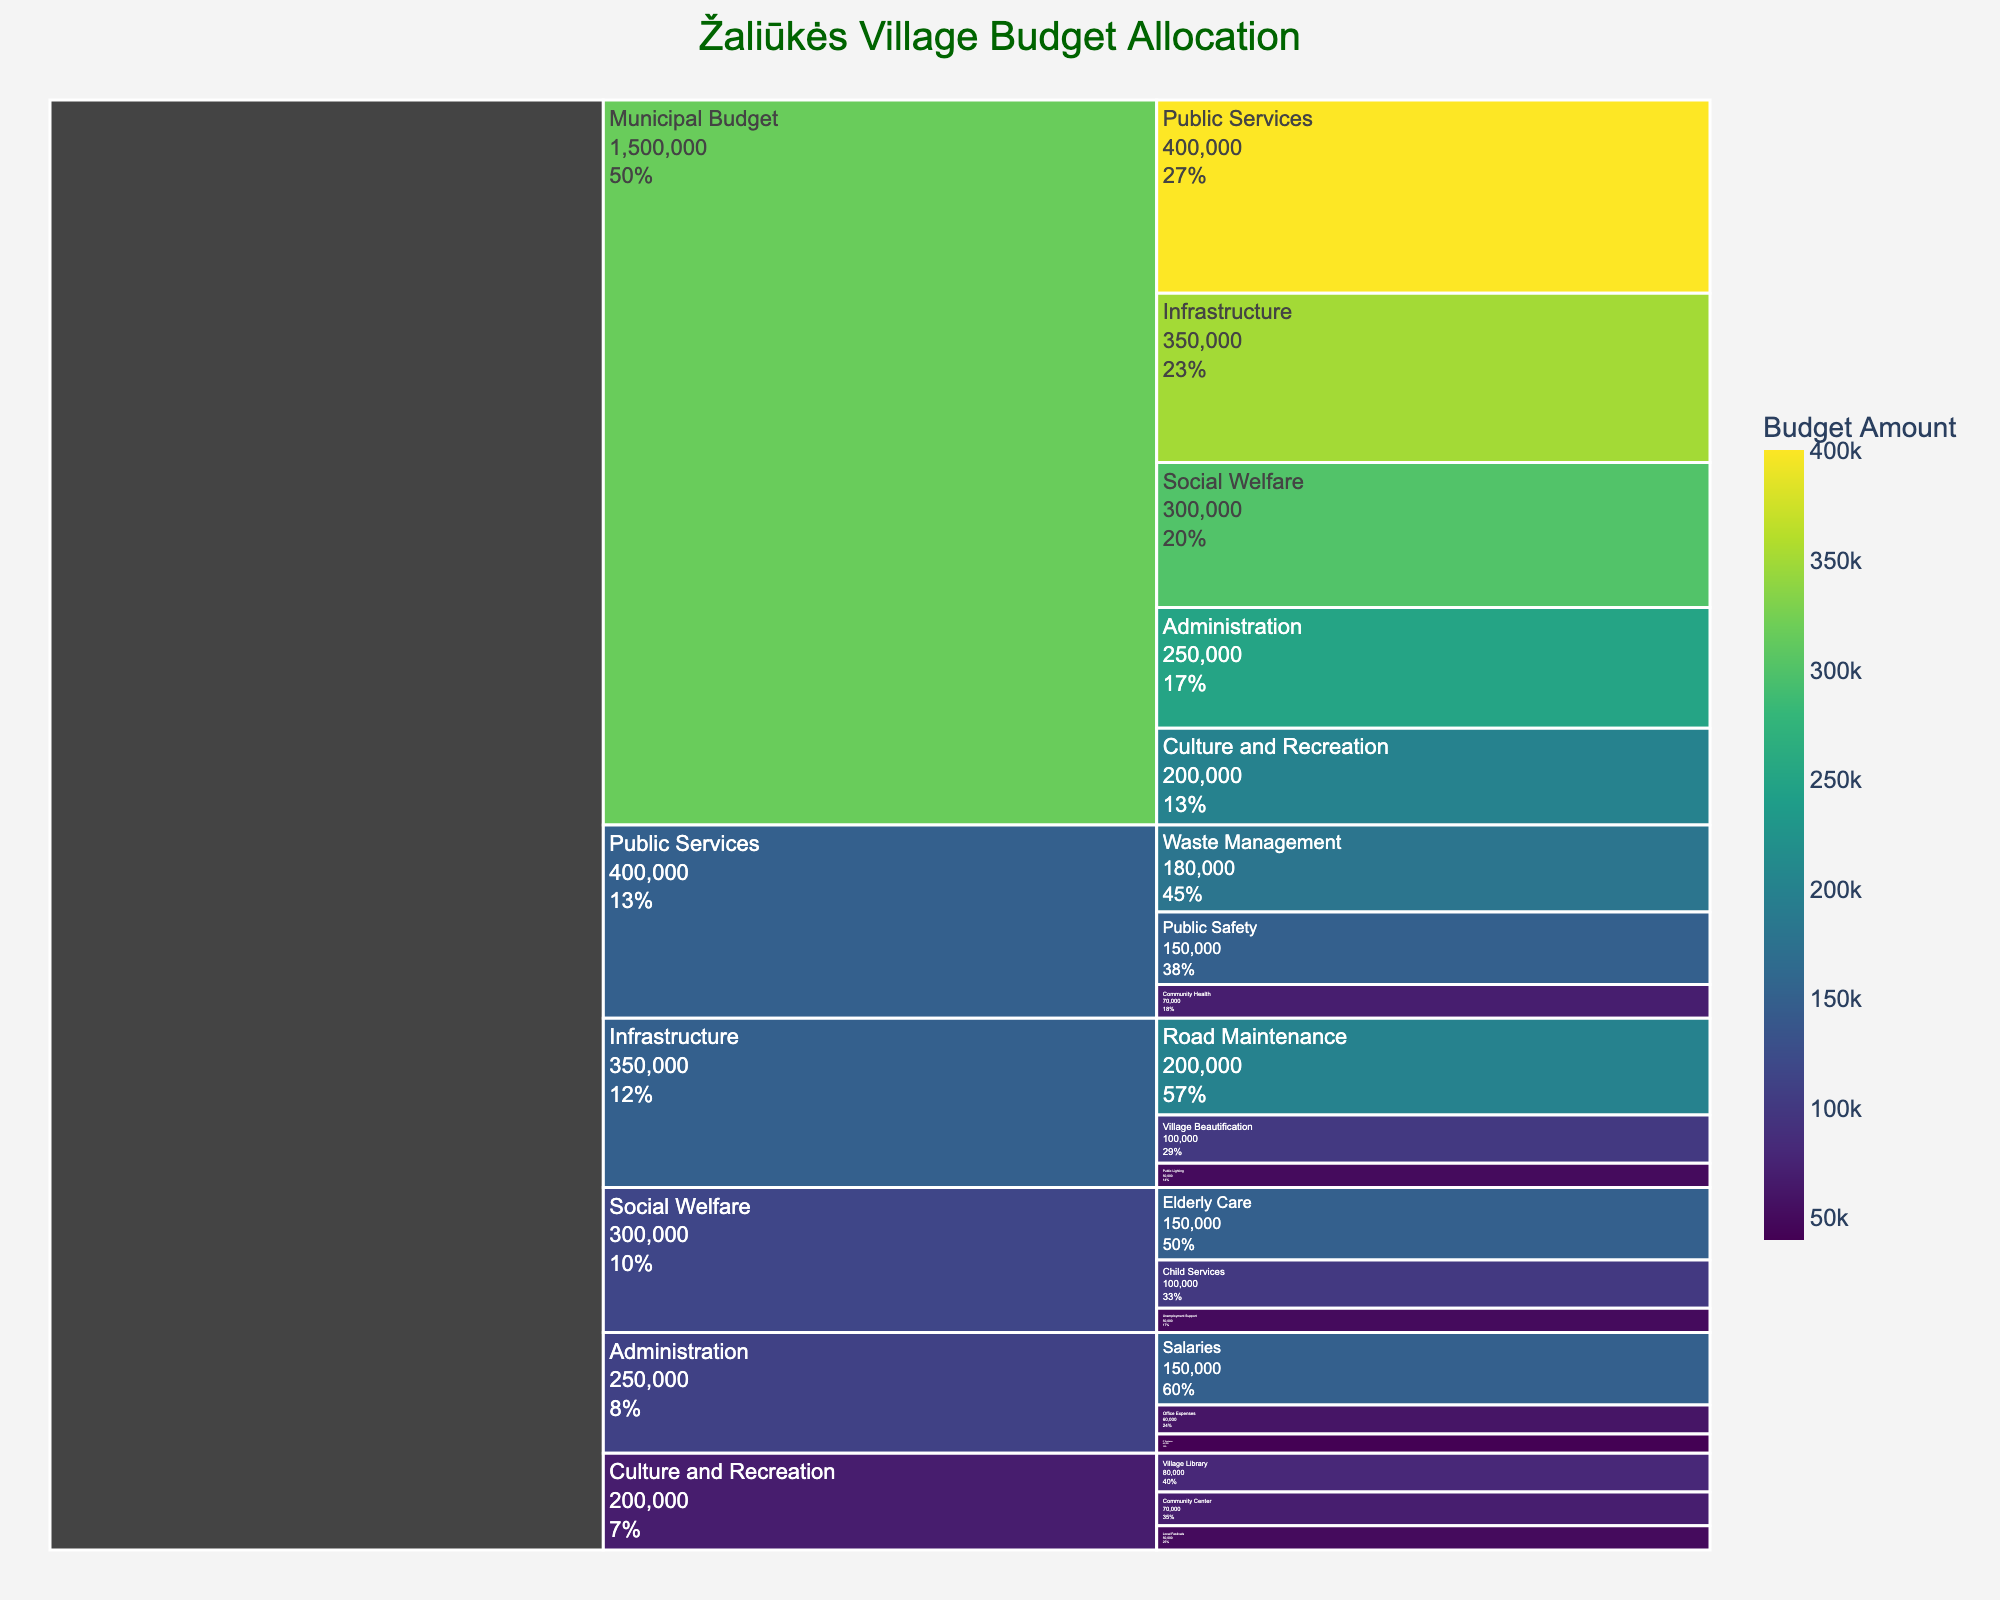What is the title of the icicle chart? The title is usually found at the top of the chart. In this case, it should clearly state the main subject being depicted, which is the budget allocation.
Answer: Žaliūkės Village Budget Allocation Which category has the highest budget allocation? To determine the category with the highest budget allocation, compare the values associated with each main category. The one with the highest number is the answer.
Answer: Public Services How much budget is allocated to Infrastructure? Locate the section labeled “Infrastructure” and note the value stated for it.
Answer: 350,000 Among the subcategories of Social Welfare, which one has the lowest budget allocation? Identify the subcategories under Social Welfare (Elderly Care, Child Services, Unemployment Support) and compare their budgets.
Answer: Unemployment Support What is the combined budget allocated to "Salaries" and "Office Expenses" within Administration? Add the values for Salaries and Office Expenses under the Administration category. Calculation: 150,000 + 60,000
Answer: 210,000 Which sector under Public Services has a budget nearly half of the Waste Management budget? Look for the subcategories under Public Services and find which value is close to half of the Waste Management budget of 180,000. 180,000 / 2 = 90,000. Public Safety at 150,000 is the closest.
Answer: Public Safety How much more is budgeted for Road Maintenance compared to Public Lighting? Subtract the budget of Public Lighting from Road Maintenance within the Infrastructure category. Calculation: 200,000 - 50,000
Answer: 150,000 Which subcategory of Culture and Recreation has the highest budget? Within the Culture and Recreation category, find and compare values of Village Library, Community Center, and Local Festivals.
Answer: Village Library What is the percentage of the total budget allocated to Village Beautification? Sum all the budgets to get the total budget, then divide the Village Beautification budget by the total and multiply by 100 for the percentage. Total Budget = 1,500,000. Calculation: (100,000 / 1,500,000) * 100
Answer: 6.67% How does the budget allocation for Child Services in the Social Welfare category compare to the budget for Office Expenses in the Administration category? Locate the budgets for Child Services (100,000) and Office Expenses (60,000) and compare the figures.
Answer: Child Services is higher by 40,000 